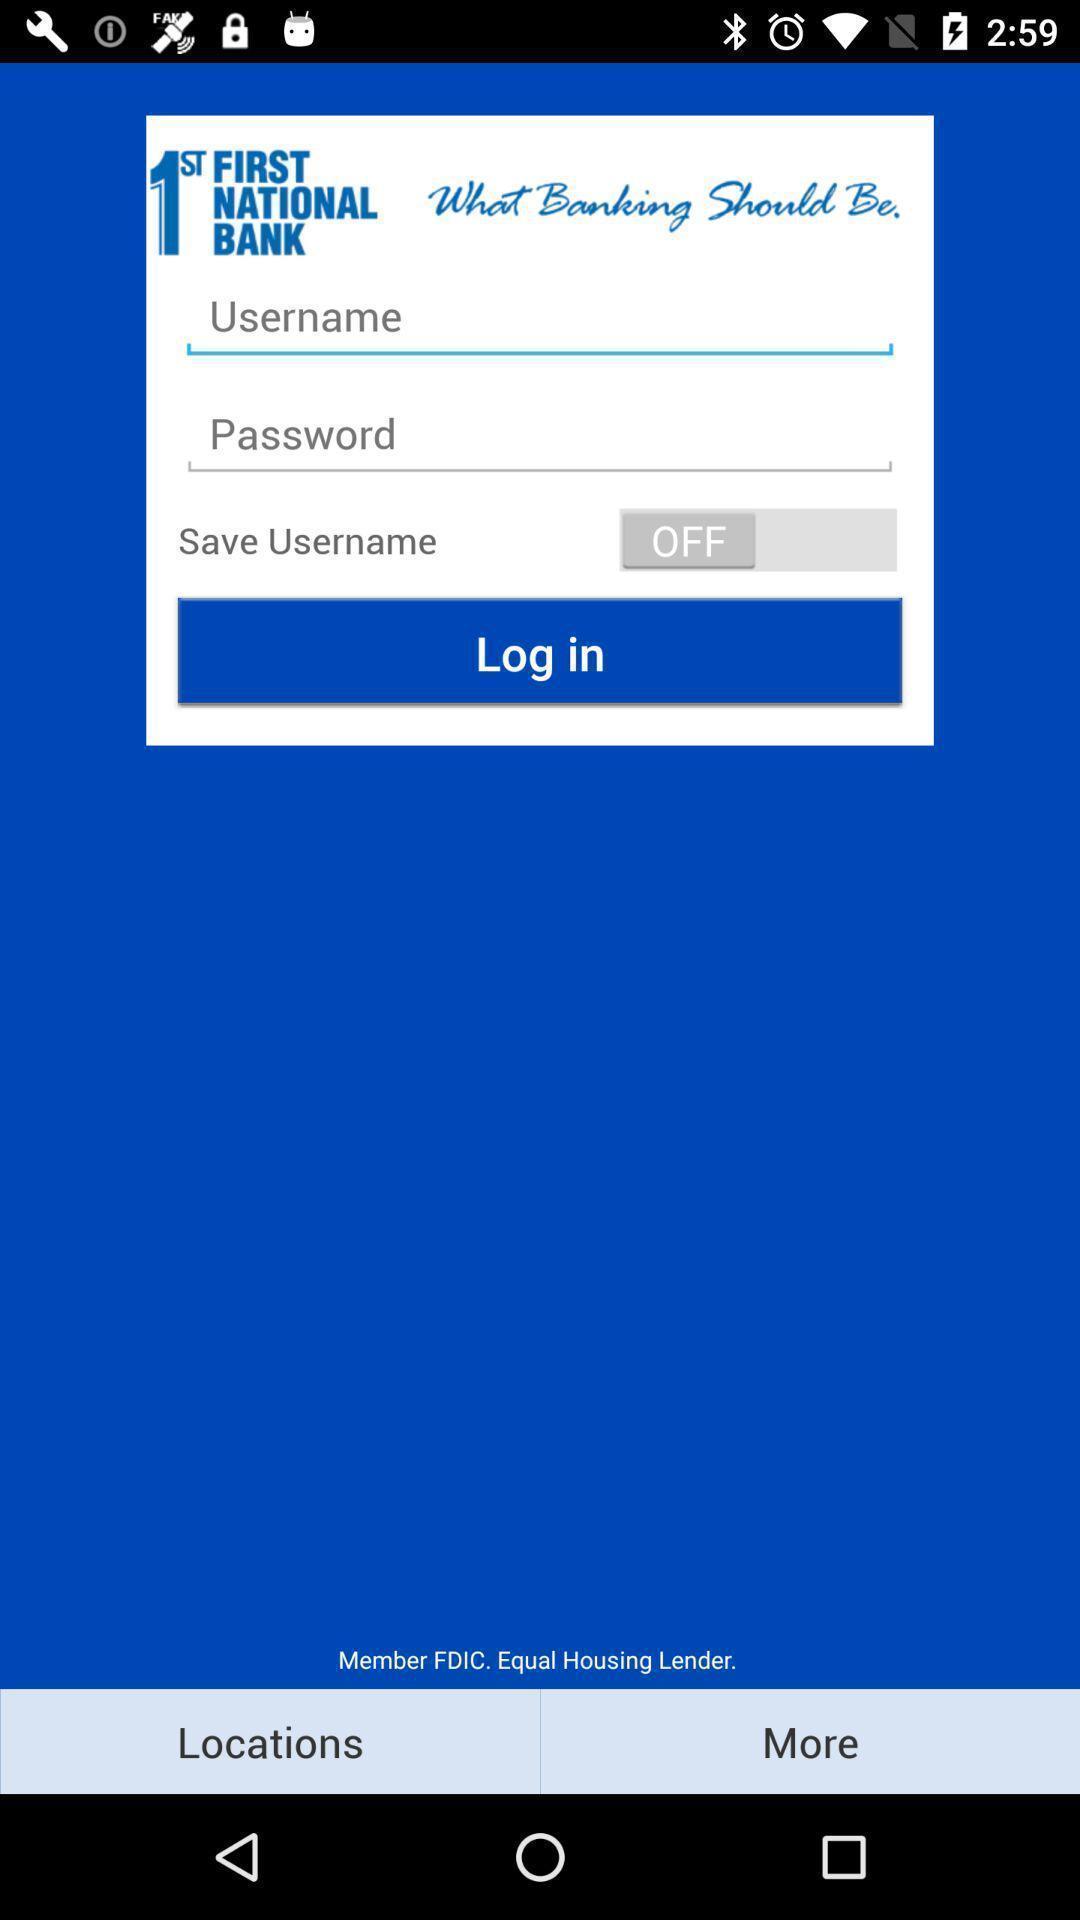Provide a description of this screenshot. Screen showing the options for input fields. 